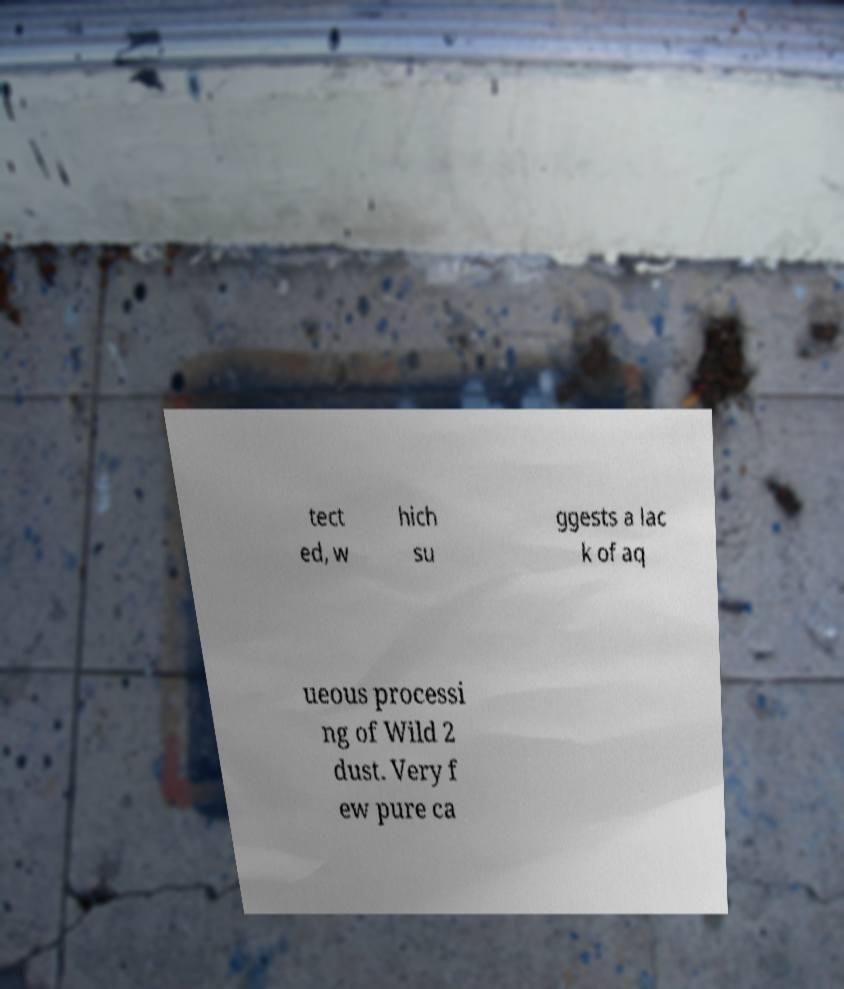What messages or text are displayed in this image? I need them in a readable, typed format. tect ed, w hich su ggests a lac k of aq ueous processi ng of Wild 2 dust. Very f ew pure ca 